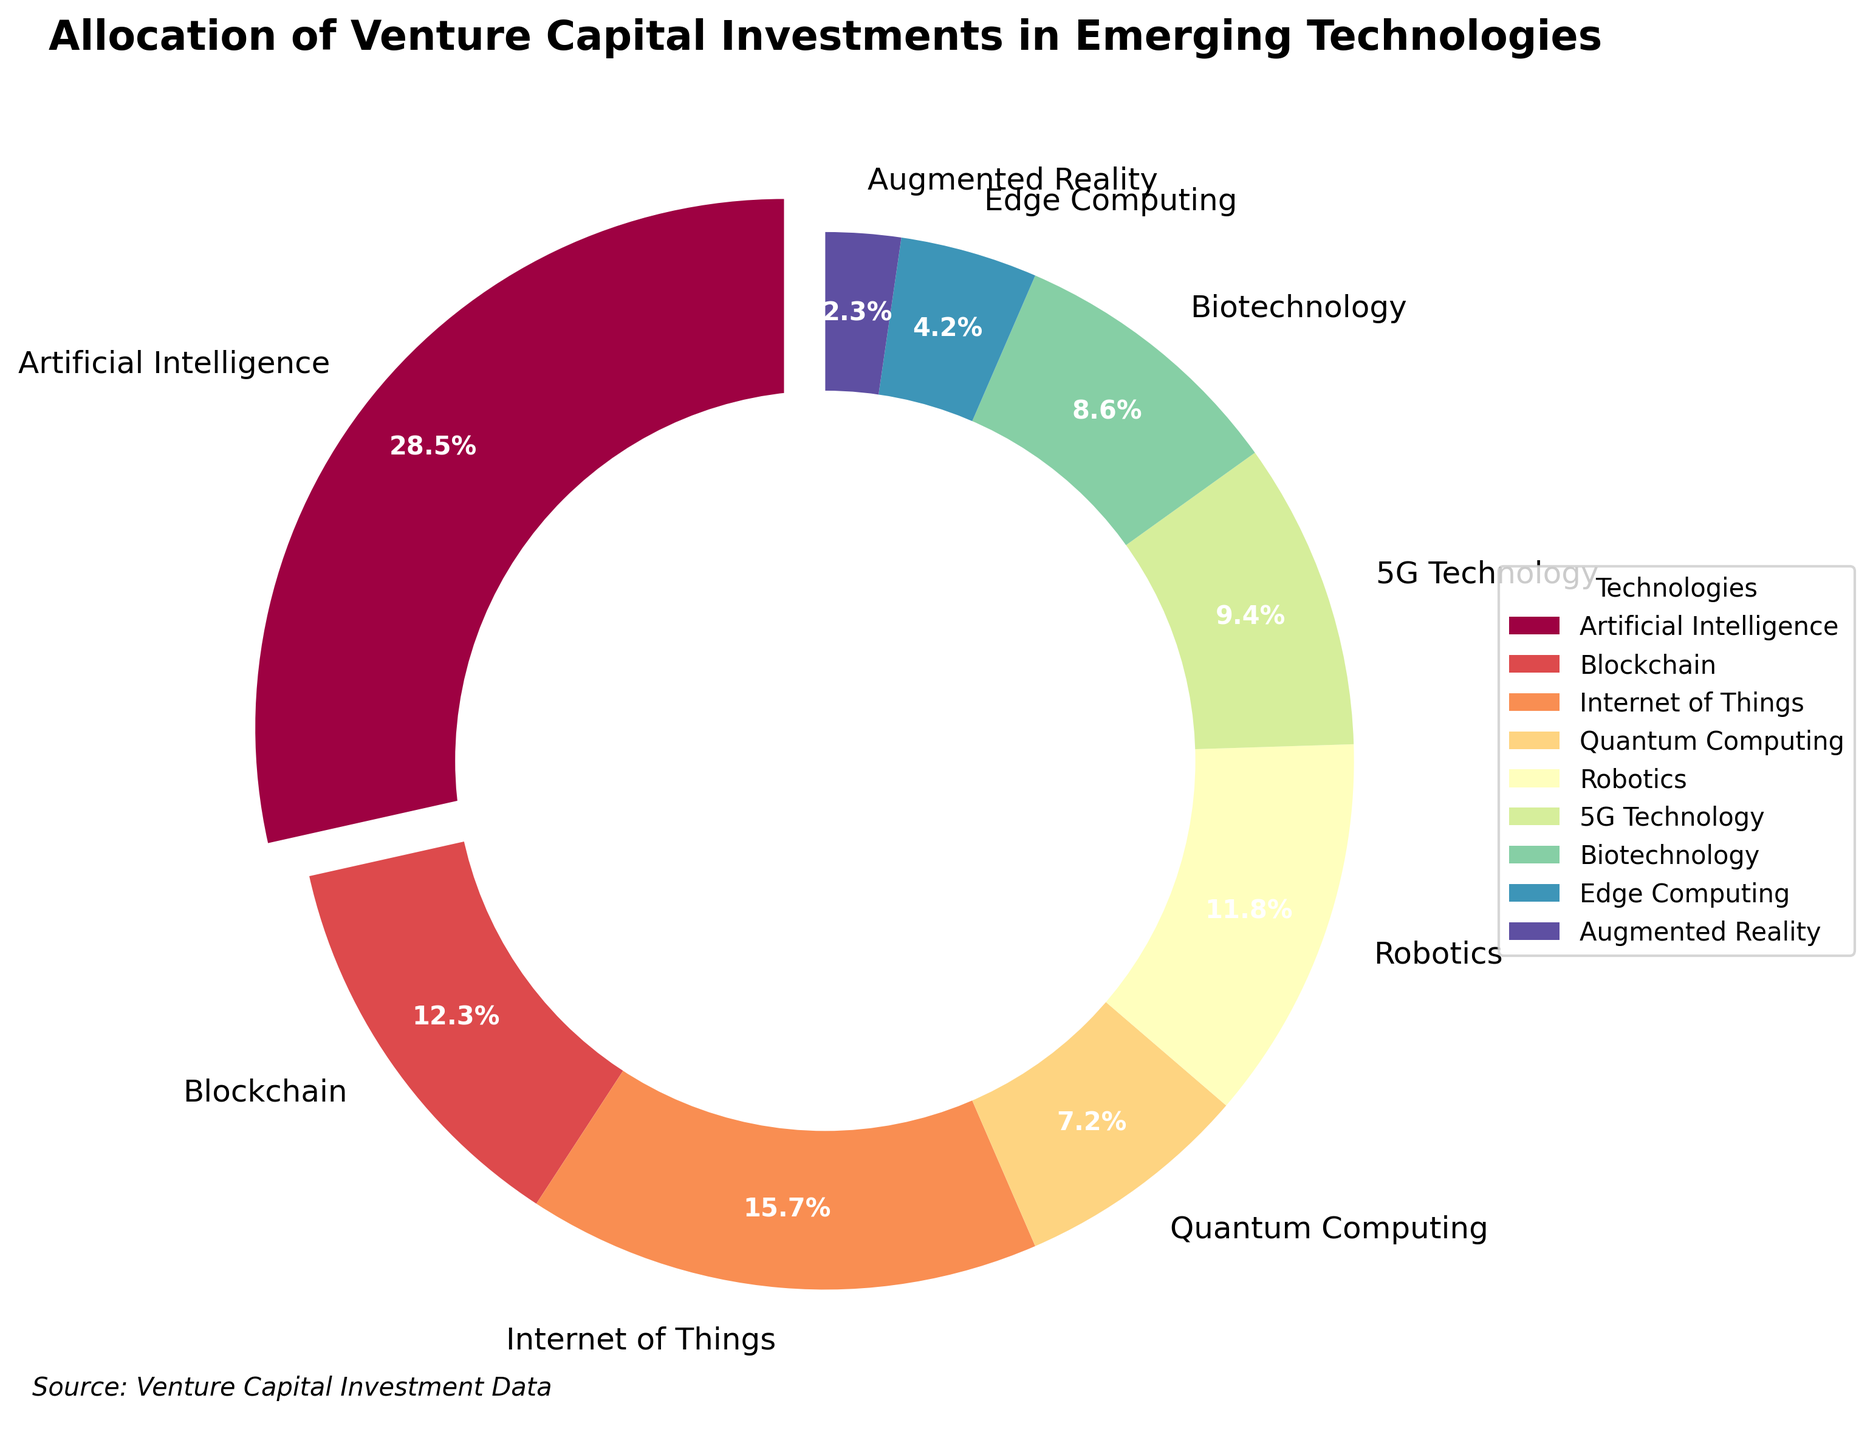Which technology received the highest percentage of venture capital investments? Look at the slice with the largest percentage in the pie chart.
Answer: Artificial Intelligence Which technology received a higher percentage of investments, Robotics or Biotechnology? Compare the slices corresponding to Robotics and Biotechnology.
Answer: Robotics What is the total percentage of investments in Artificial Intelligence and Blockchain combined? Sum the percentages of Artificial Intelligence (28.5%) and Blockchain (12.3%).
Answer: 40.8% Among Blockchain, Internet of Things, and Quantum Computing, which technology received the lowest investment? Identify the smallest percentage among the three mentioned slices.
Answer: Quantum Computing How much more investment did Internet of Things receive compared to Edge Computing? Subtract Edge Computing's percentage (4.2%) from Internet of Things' percentage (15.7%).
Answer: 11.5% Which two technologies together form exactly 20% of the investments? Look for two slices of the pie chart whose percentages sum up to 20%.
Answer: 5G Technology (9.4%) and Biotechnology (8.6%) Which color represents the slice for Artificial Intelligence? Identify the color of the largest exploded slice.
Answer: The specific color depends on the color scheme used, identified by the user visually Combined, do the investments in Quantum Computing and Augmented Reality exceed those in 5G Technology? Sum the percentages of Quantum Computing (7.2%) and Augmented Reality (2.3%) and compare with 5G Technology (9.4%).
Answer: No What is the average percentage of investments received by Internet of Things, 5G Technology, and Robotics? Sum the percentages of Internet of Things (15.7%), 5G Technology (9.4%), and Robotics (11.8%), then divide by 3. (15.7 + 9.4 + 11.8) / 3
Answer: 12.3 Which technology has a larger investment, Biotechnology or Edge Computing? By how much? Subtract Edge Computing's percentage (4.2%) from Biotechnology's percentage (8.6%).
Answer: Biotechnology, by 4.4 